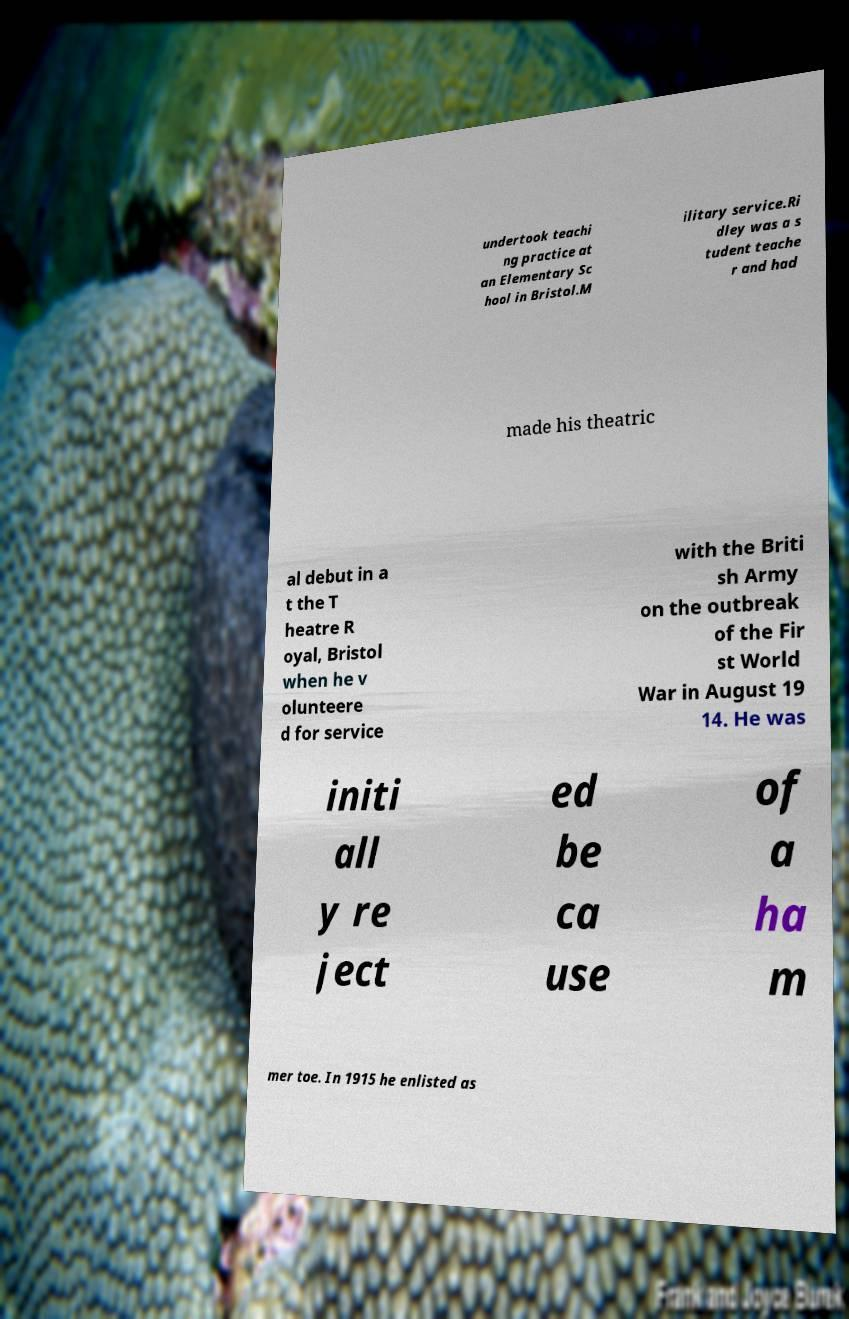There's text embedded in this image that I need extracted. Can you transcribe it verbatim? undertook teachi ng practice at an Elementary Sc hool in Bristol.M ilitary service.Ri dley was a s tudent teache r and had made his theatric al debut in a t the T heatre R oyal, Bristol when he v olunteere d for service with the Briti sh Army on the outbreak of the Fir st World War in August 19 14. He was initi all y re ject ed be ca use of a ha m mer toe. In 1915 he enlisted as 